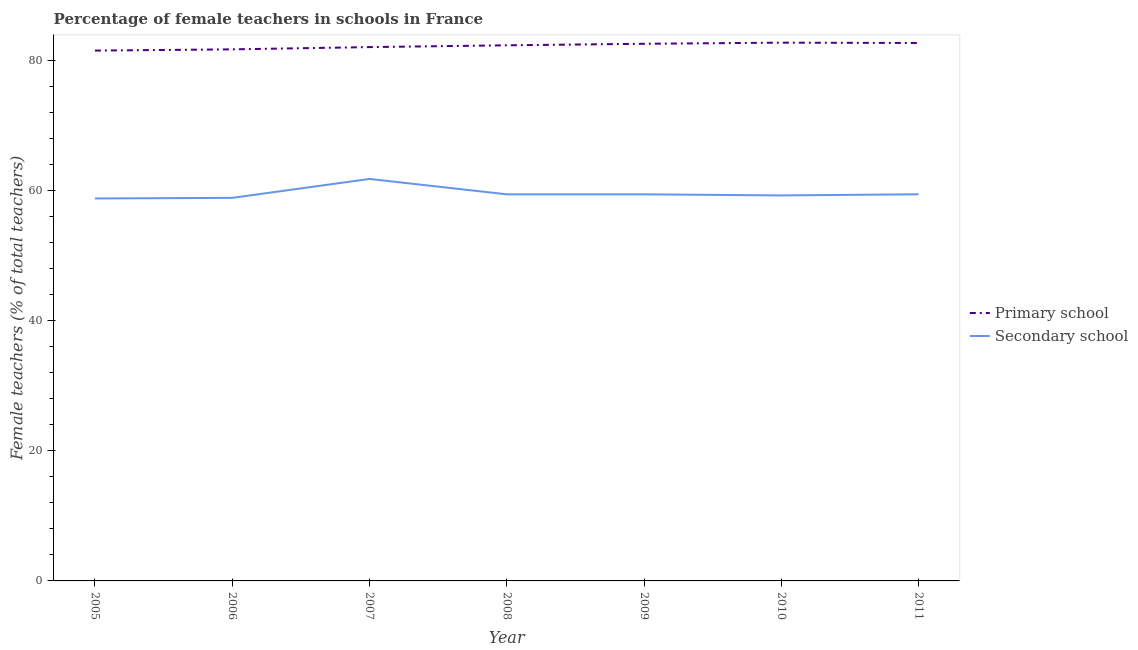Does the line corresponding to percentage of female teachers in secondary schools intersect with the line corresponding to percentage of female teachers in primary schools?
Provide a succinct answer. No. Is the number of lines equal to the number of legend labels?
Offer a terse response. Yes. What is the percentage of female teachers in secondary schools in 2010?
Offer a very short reply. 59.28. Across all years, what is the maximum percentage of female teachers in primary schools?
Your answer should be very brief. 82.77. Across all years, what is the minimum percentage of female teachers in primary schools?
Give a very brief answer. 81.55. In which year was the percentage of female teachers in secondary schools maximum?
Ensure brevity in your answer.  2007. What is the total percentage of female teachers in primary schools in the graph?
Give a very brief answer. 575.82. What is the difference between the percentage of female teachers in primary schools in 2005 and that in 2011?
Your response must be concise. -1.17. What is the difference between the percentage of female teachers in secondary schools in 2005 and the percentage of female teachers in primary schools in 2010?
Offer a terse response. -23.95. What is the average percentage of female teachers in primary schools per year?
Keep it short and to the point. 82.26. In the year 2008, what is the difference between the percentage of female teachers in secondary schools and percentage of female teachers in primary schools?
Offer a very short reply. -22.91. In how many years, is the percentage of female teachers in primary schools greater than 68 %?
Provide a succinct answer. 7. What is the ratio of the percentage of female teachers in secondary schools in 2005 to that in 2008?
Provide a short and direct response. 0.99. Is the percentage of female teachers in secondary schools in 2008 less than that in 2009?
Your answer should be compact. Yes. Is the difference between the percentage of female teachers in secondary schools in 2009 and 2011 greater than the difference between the percentage of female teachers in primary schools in 2009 and 2011?
Keep it short and to the point. Yes. What is the difference between the highest and the second highest percentage of female teachers in secondary schools?
Offer a terse response. 2.36. What is the difference between the highest and the lowest percentage of female teachers in primary schools?
Offer a terse response. 1.22. In how many years, is the percentage of female teachers in secondary schools greater than the average percentage of female teachers in secondary schools taken over all years?
Your answer should be very brief. 1. Is the sum of the percentage of female teachers in primary schools in 2006 and 2007 greater than the maximum percentage of female teachers in secondary schools across all years?
Offer a terse response. Yes. Does the percentage of female teachers in secondary schools monotonically increase over the years?
Keep it short and to the point. No. Is the percentage of female teachers in primary schools strictly less than the percentage of female teachers in secondary schools over the years?
Provide a succinct answer. No. Does the graph contain any zero values?
Give a very brief answer. No. How are the legend labels stacked?
Your response must be concise. Vertical. What is the title of the graph?
Provide a short and direct response. Percentage of female teachers in schools in France. Does "Age 65(female)" appear as one of the legend labels in the graph?
Your response must be concise. No. What is the label or title of the X-axis?
Ensure brevity in your answer.  Year. What is the label or title of the Y-axis?
Keep it short and to the point. Female teachers (% of total teachers). What is the Female teachers (% of total teachers) of Primary school in 2005?
Keep it short and to the point. 81.55. What is the Female teachers (% of total teachers) of Secondary school in 2005?
Offer a terse response. 58.81. What is the Female teachers (% of total teachers) of Primary school in 2006?
Ensure brevity in your answer.  81.74. What is the Female teachers (% of total teachers) in Secondary school in 2006?
Make the answer very short. 58.9. What is the Female teachers (% of total teachers) in Primary school in 2007?
Offer a very short reply. 82.09. What is the Female teachers (% of total teachers) of Secondary school in 2007?
Offer a very short reply. 61.81. What is the Female teachers (% of total teachers) in Primary school in 2008?
Ensure brevity in your answer.  82.36. What is the Female teachers (% of total teachers) in Secondary school in 2008?
Give a very brief answer. 59.45. What is the Female teachers (% of total teachers) in Primary school in 2009?
Provide a short and direct response. 82.6. What is the Female teachers (% of total teachers) of Secondary school in 2009?
Your answer should be compact. 59.45. What is the Female teachers (% of total teachers) in Primary school in 2010?
Give a very brief answer. 82.77. What is the Female teachers (% of total teachers) in Secondary school in 2010?
Offer a very short reply. 59.28. What is the Female teachers (% of total teachers) in Primary school in 2011?
Offer a very short reply. 82.72. What is the Female teachers (% of total teachers) in Secondary school in 2011?
Give a very brief answer. 59.45. Across all years, what is the maximum Female teachers (% of total teachers) of Primary school?
Your answer should be very brief. 82.77. Across all years, what is the maximum Female teachers (% of total teachers) in Secondary school?
Keep it short and to the point. 61.81. Across all years, what is the minimum Female teachers (% of total teachers) in Primary school?
Ensure brevity in your answer.  81.55. Across all years, what is the minimum Female teachers (% of total teachers) in Secondary school?
Your response must be concise. 58.81. What is the total Female teachers (% of total teachers) of Primary school in the graph?
Ensure brevity in your answer.  575.82. What is the total Female teachers (% of total teachers) in Secondary school in the graph?
Your response must be concise. 417.15. What is the difference between the Female teachers (% of total teachers) in Primary school in 2005 and that in 2006?
Your answer should be compact. -0.19. What is the difference between the Female teachers (% of total teachers) of Secondary school in 2005 and that in 2006?
Ensure brevity in your answer.  -0.09. What is the difference between the Female teachers (% of total teachers) of Primary school in 2005 and that in 2007?
Make the answer very short. -0.54. What is the difference between the Female teachers (% of total teachers) in Secondary school in 2005 and that in 2007?
Provide a succinct answer. -3. What is the difference between the Female teachers (% of total teachers) of Primary school in 2005 and that in 2008?
Offer a terse response. -0.81. What is the difference between the Female teachers (% of total teachers) of Secondary school in 2005 and that in 2008?
Keep it short and to the point. -0.63. What is the difference between the Female teachers (% of total teachers) of Primary school in 2005 and that in 2009?
Your answer should be very brief. -1.05. What is the difference between the Female teachers (% of total teachers) of Secondary school in 2005 and that in 2009?
Your answer should be compact. -0.63. What is the difference between the Female teachers (% of total teachers) in Primary school in 2005 and that in 2010?
Offer a very short reply. -1.22. What is the difference between the Female teachers (% of total teachers) in Secondary school in 2005 and that in 2010?
Your answer should be very brief. -0.46. What is the difference between the Female teachers (% of total teachers) in Primary school in 2005 and that in 2011?
Your response must be concise. -1.17. What is the difference between the Female teachers (% of total teachers) of Secondary school in 2005 and that in 2011?
Offer a terse response. -0.64. What is the difference between the Female teachers (% of total teachers) of Primary school in 2006 and that in 2007?
Your response must be concise. -0.35. What is the difference between the Female teachers (% of total teachers) of Secondary school in 2006 and that in 2007?
Offer a very short reply. -2.91. What is the difference between the Female teachers (% of total teachers) in Primary school in 2006 and that in 2008?
Make the answer very short. -0.62. What is the difference between the Female teachers (% of total teachers) in Secondary school in 2006 and that in 2008?
Provide a short and direct response. -0.54. What is the difference between the Female teachers (% of total teachers) in Primary school in 2006 and that in 2009?
Ensure brevity in your answer.  -0.86. What is the difference between the Female teachers (% of total teachers) of Secondary school in 2006 and that in 2009?
Give a very brief answer. -0.54. What is the difference between the Female teachers (% of total teachers) of Primary school in 2006 and that in 2010?
Offer a very short reply. -1.03. What is the difference between the Female teachers (% of total teachers) of Secondary school in 2006 and that in 2010?
Make the answer very short. -0.37. What is the difference between the Female teachers (% of total teachers) of Primary school in 2006 and that in 2011?
Make the answer very short. -0.98. What is the difference between the Female teachers (% of total teachers) in Secondary school in 2006 and that in 2011?
Offer a very short reply. -0.55. What is the difference between the Female teachers (% of total teachers) of Primary school in 2007 and that in 2008?
Your answer should be very brief. -0.28. What is the difference between the Female teachers (% of total teachers) in Secondary school in 2007 and that in 2008?
Your response must be concise. 2.37. What is the difference between the Female teachers (% of total teachers) of Primary school in 2007 and that in 2009?
Ensure brevity in your answer.  -0.51. What is the difference between the Female teachers (% of total teachers) of Secondary school in 2007 and that in 2009?
Your answer should be very brief. 2.36. What is the difference between the Female teachers (% of total teachers) in Primary school in 2007 and that in 2010?
Make the answer very short. -0.68. What is the difference between the Female teachers (% of total teachers) of Secondary school in 2007 and that in 2010?
Your answer should be very brief. 2.54. What is the difference between the Female teachers (% of total teachers) of Primary school in 2007 and that in 2011?
Give a very brief answer. -0.63. What is the difference between the Female teachers (% of total teachers) of Secondary school in 2007 and that in 2011?
Your answer should be very brief. 2.36. What is the difference between the Female teachers (% of total teachers) in Primary school in 2008 and that in 2009?
Provide a short and direct response. -0.23. What is the difference between the Female teachers (% of total teachers) in Secondary school in 2008 and that in 2009?
Offer a terse response. -0. What is the difference between the Female teachers (% of total teachers) in Primary school in 2008 and that in 2010?
Your answer should be compact. -0.41. What is the difference between the Female teachers (% of total teachers) of Secondary school in 2008 and that in 2010?
Your answer should be very brief. 0.17. What is the difference between the Female teachers (% of total teachers) in Primary school in 2008 and that in 2011?
Give a very brief answer. -0.36. What is the difference between the Female teachers (% of total teachers) in Secondary school in 2008 and that in 2011?
Ensure brevity in your answer.  -0.01. What is the difference between the Female teachers (% of total teachers) in Primary school in 2009 and that in 2010?
Provide a short and direct response. -0.17. What is the difference between the Female teachers (% of total teachers) in Secondary school in 2009 and that in 2010?
Your answer should be compact. 0.17. What is the difference between the Female teachers (% of total teachers) of Primary school in 2009 and that in 2011?
Your answer should be compact. -0.12. What is the difference between the Female teachers (% of total teachers) in Secondary school in 2009 and that in 2011?
Keep it short and to the point. -0.01. What is the difference between the Female teachers (% of total teachers) of Primary school in 2010 and that in 2011?
Ensure brevity in your answer.  0.05. What is the difference between the Female teachers (% of total teachers) of Secondary school in 2010 and that in 2011?
Your answer should be very brief. -0.18. What is the difference between the Female teachers (% of total teachers) of Primary school in 2005 and the Female teachers (% of total teachers) of Secondary school in 2006?
Offer a terse response. 22.65. What is the difference between the Female teachers (% of total teachers) of Primary school in 2005 and the Female teachers (% of total teachers) of Secondary school in 2007?
Your response must be concise. 19.74. What is the difference between the Female teachers (% of total teachers) in Primary school in 2005 and the Female teachers (% of total teachers) in Secondary school in 2008?
Provide a succinct answer. 22.1. What is the difference between the Female teachers (% of total teachers) in Primary school in 2005 and the Female teachers (% of total teachers) in Secondary school in 2009?
Your answer should be compact. 22.1. What is the difference between the Female teachers (% of total teachers) of Primary school in 2005 and the Female teachers (% of total teachers) of Secondary school in 2010?
Your response must be concise. 22.27. What is the difference between the Female teachers (% of total teachers) in Primary school in 2005 and the Female teachers (% of total teachers) in Secondary school in 2011?
Your answer should be very brief. 22.1. What is the difference between the Female teachers (% of total teachers) of Primary school in 2006 and the Female teachers (% of total teachers) of Secondary school in 2007?
Your response must be concise. 19.93. What is the difference between the Female teachers (% of total teachers) in Primary school in 2006 and the Female teachers (% of total teachers) in Secondary school in 2008?
Ensure brevity in your answer.  22.29. What is the difference between the Female teachers (% of total teachers) in Primary school in 2006 and the Female teachers (% of total teachers) in Secondary school in 2009?
Provide a succinct answer. 22.29. What is the difference between the Female teachers (% of total teachers) in Primary school in 2006 and the Female teachers (% of total teachers) in Secondary school in 2010?
Make the answer very short. 22.46. What is the difference between the Female teachers (% of total teachers) of Primary school in 2006 and the Female teachers (% of total teachers) of Secondary school in 2011?
Keep it short and to the point. 22.28. What is the difference between the Female teachers (% of total teachers) of Primary school in 2007 and the Female teachers (% of total teachers) of Secondary school in 2008?
Offer a very short reply. 22.64. What is the difference between the Female teachers (% of total teachers) of Primary school in 2007 and the Female teachers (% of total teachers) of Secondary school in 2009?
Provide a short and direct response. 22.64. What is the difference between the Female teachers (% of total teachers) of Primary school in 2007 and the Female teachers (% of total teachers) of Secondary school in 2010?
Offer a very short reply. 22.81. What is the difference between the Female teachers (% of total teachers) in Primary school in 2007 and the Female teachers (% of total teachers) in Secondary school in 2011?
Your answer should be very brief. 22.63. What is the difference between the Female teachers (% of total teachers) of Primary school in 2008 and the Female teachers (% of total teachers) of Secondary school in 2009?
Your answer should be compact. 22.91. What is the difference between the Female teachers (% of total teachers) in Primary school in 2008 and the Female teachers (% of total teachers) in Secondary school in 2010?
Ensure brevity in your answer.  23.09. What is the difference between the Female teachers (% of total teachers) in Primary school in 2008 and the Female teachers (% of total teachers) in Secondary school in 2011?
Keep it short and to the point. 22.91. What is the difference between the Female teachers (% of total teachers) in Primary school in 2009 and the Female teachers (% of total teachers) in Secondary school in 2010?
Offer a terse response. 23.32. What is the difference between the Female teachers (% of total teachers) of Primary school in 2009 and the Female teachers (% of total teachers) of Secondary school in 2011?
Offer a very short reply. 23.14. What is the difference between the Female teachers (% of total teachers) of Primary school in 2010 and the Female teachers (% of total teachers) of Secondary school in 2011?
Provide a short and direct response. 23.31. What is the average Female teachers (% of total teachers) in Primary school per year?
Ensure brevity in your answer.  82.26. What is the average Female teachers (% of total teachers) of Secondary school per year?
Provide a short and direct response. 59.59. In the year 2005, what is the difference between the Female teachers (% of total teachers) of Primary school and Female teachers (% of total teachers) of Secondary school?
Your answer should be compact. 22.74. In the year 2006, what is the difference between the Female teachers (% of total teachers) in Primary school and Female teachers (% of total teachers) in Secondary school?
Your answer should be very brief. 22.84. In the year 2007, what is the difference between the Female teachers (% of total teachers) in Primary school and Female teachers (% of total teachers) in Secondary school?
Offer a very short reply. 20.27. In the year 2008, what is the difference between the Female teachers (% of total teachers) in Primary school and Female teachers (% of total teachers) in Secondary school?
Provide a short and direct response. 22.91. In the year 2009, what is the difference between the Female teachers (% of total teachers) of Primary school and Female teachers (% of total teachers) of Secondary school?
Ensure brevity in your answer.  23.15. In the year 2010, what is the difference between the Female teachers (% of total teachers) of Primary school and Female teachers (% of total teachers) of Secondary school?
Your answer should be compact. 23.49. In the year 2011, what is the difference between the Female teachers (% of total teachers) of Primary school and Female teachers (% of total teachers) of Secondary school?
Provide a short and direct response. 23.26. What is the ratio of the Female teachers (% of total teachers) of Primary school in 2005 to that in 2007?
Keep it short and to the point. 0.99. What is the ratio of the Female teachers (% of total teachers) in Secondary school in 2005 to that in 2007?
Your answer should be compact. 0.95. What is the ratio of the Female teachers (% of total teachers) in Primary school in 2005 to that in 2008?
Offer a terse response. 0.99. What is the ratio of the Female teachers (% of total teachers) in Secondary school in 2005 to that in 2008?
Provide a short and direct response. 0.99. What is the ratio of the Female teachers (% of total teachers) of Primary school in 2005 to that in 2009?
Keep it short and to the point. 0.99. What is the ratio of the Female teachers (% of total teachers) in Secondary school in 2005 to that in 2009?
Provide a succinct answer. 0.99. What is the ratio of the Female teachers (% of total teachers) of Primary school in 2005 to that in 2011?
Make the answer very short. 0.99. What is the ratio of the Female teachers (% of total teachers) of Primary school in 2006 to that in 2007?
Make the answer very short. 1. What is the ratio of the Female teachers (% of total teachers) of Secondary school in 2006 to that in 2007?
Offer a very short reply. 0.95. What is the ratio of the Female teachers (% of total teachers) in Secondary school in 2006 to that in 2008?
Give a very brief answer. 0.99. What is the ratio of the Female teachers (% of total teachers) in Primary school in 2006 to that in 2009?
Make the answer very short. 0.99. What is the ratio of the Female teachers (% of total teachers) in Secondary school in 2006 to that in 2009?
Provide a short and direct response. 0.99. What is the ratio of the Female teachers (% of total teachers) of Primary school in 2006 to that in 2010?
Offer a terse response. 0.99. What is the ratio of the Female teachers (% of total teachers) in Secondary school in 2006 to that in 2011?
Make the answer very short. 0.99. What is the ratio of the Female teachers (% of total teachers) in Primary school in 2007 to that in 2008?
Your answer should be very brief. 1. What is the ratio of the Female teachers (% of total teachers) in Secondary school in 2007 to that in 2008?
Give a very brief answer. 1.04. What is the ratio of the Female teachers (% of total teachers) of Primary school in 2007 to that in 2009?
Keep it short and to the point. 0.99. What is the ratio of the Female teachers (% of total teachers) of Secondary school in 2007 to that in 2009?
Your response must be concise. 1.04. What is the ratio of the Female teachers (% of total teachers) in Primary school in 2007 to that in 2010?
Ensure brevity in your answer.  0.99. What is the ratio of the Female teachers (% of total teachers) of Secondary school in 2007 to that in 2010?
Provide a succinct answer. 1.04. What is the ratio of the Female teachers (% of total teachers) of Primary school in 2007 to that in 2011?
Offer a very short reply. 0.99. What is the ratio of the Female teachers (% of total teachers) in Secondary school in 2007 to that in 2011?
Keep it short and to the point. 1.04. What is the ratio of the Female teachers (% of total teachers) of Primary school in 2008 to that in 2009?
Keep it short and to the point. 1. What is the ratio of the Female teachers (% of total teachers) in Secondary school in 2008 to that in 2009?
Your response must be concise. 1. What is the ratio of the Female teachers (% of total teachers) in Primary school in 2008 to that in 2010?
Give a very brief answer. 1. What is the ratio of the Female teachers (% of total teachers) of Secondary school in 2008 to that in 2010?
Give a very brief answer. 1. What is the ratio of the Female teachers (% of total teachers) in Primary school in 2008 to that in 2011?
Provide a short and direct response. 1. What is the ratio of the Female teachers (% of total teachers) in Primary school in 2009 to that in 2010?
Keep it short and to the point. 1. What is the ratio of the Female teachers (% of total teachers) of Secondary school in 2009 to that in 2010?
Your answer should be very brief. 1. What is the difference between the highest and the second highest Female teachers (% of total teachers) of Primary school?
Your response must be concise. 0.05. What is the difference between the highest and the second highest Female teachers (% of total teachers) of Secondary school?
Keep it short and to the point. 2.36. What is the difference between the highest and the lowest Female teachers (% of total teachers) of Primary school?
Offer a terse response. 1.22. What is the difference between the highest and the lowest Female teachers (% of total teachers) in Secondary school?
Ensure brevity in your answer.  3. 